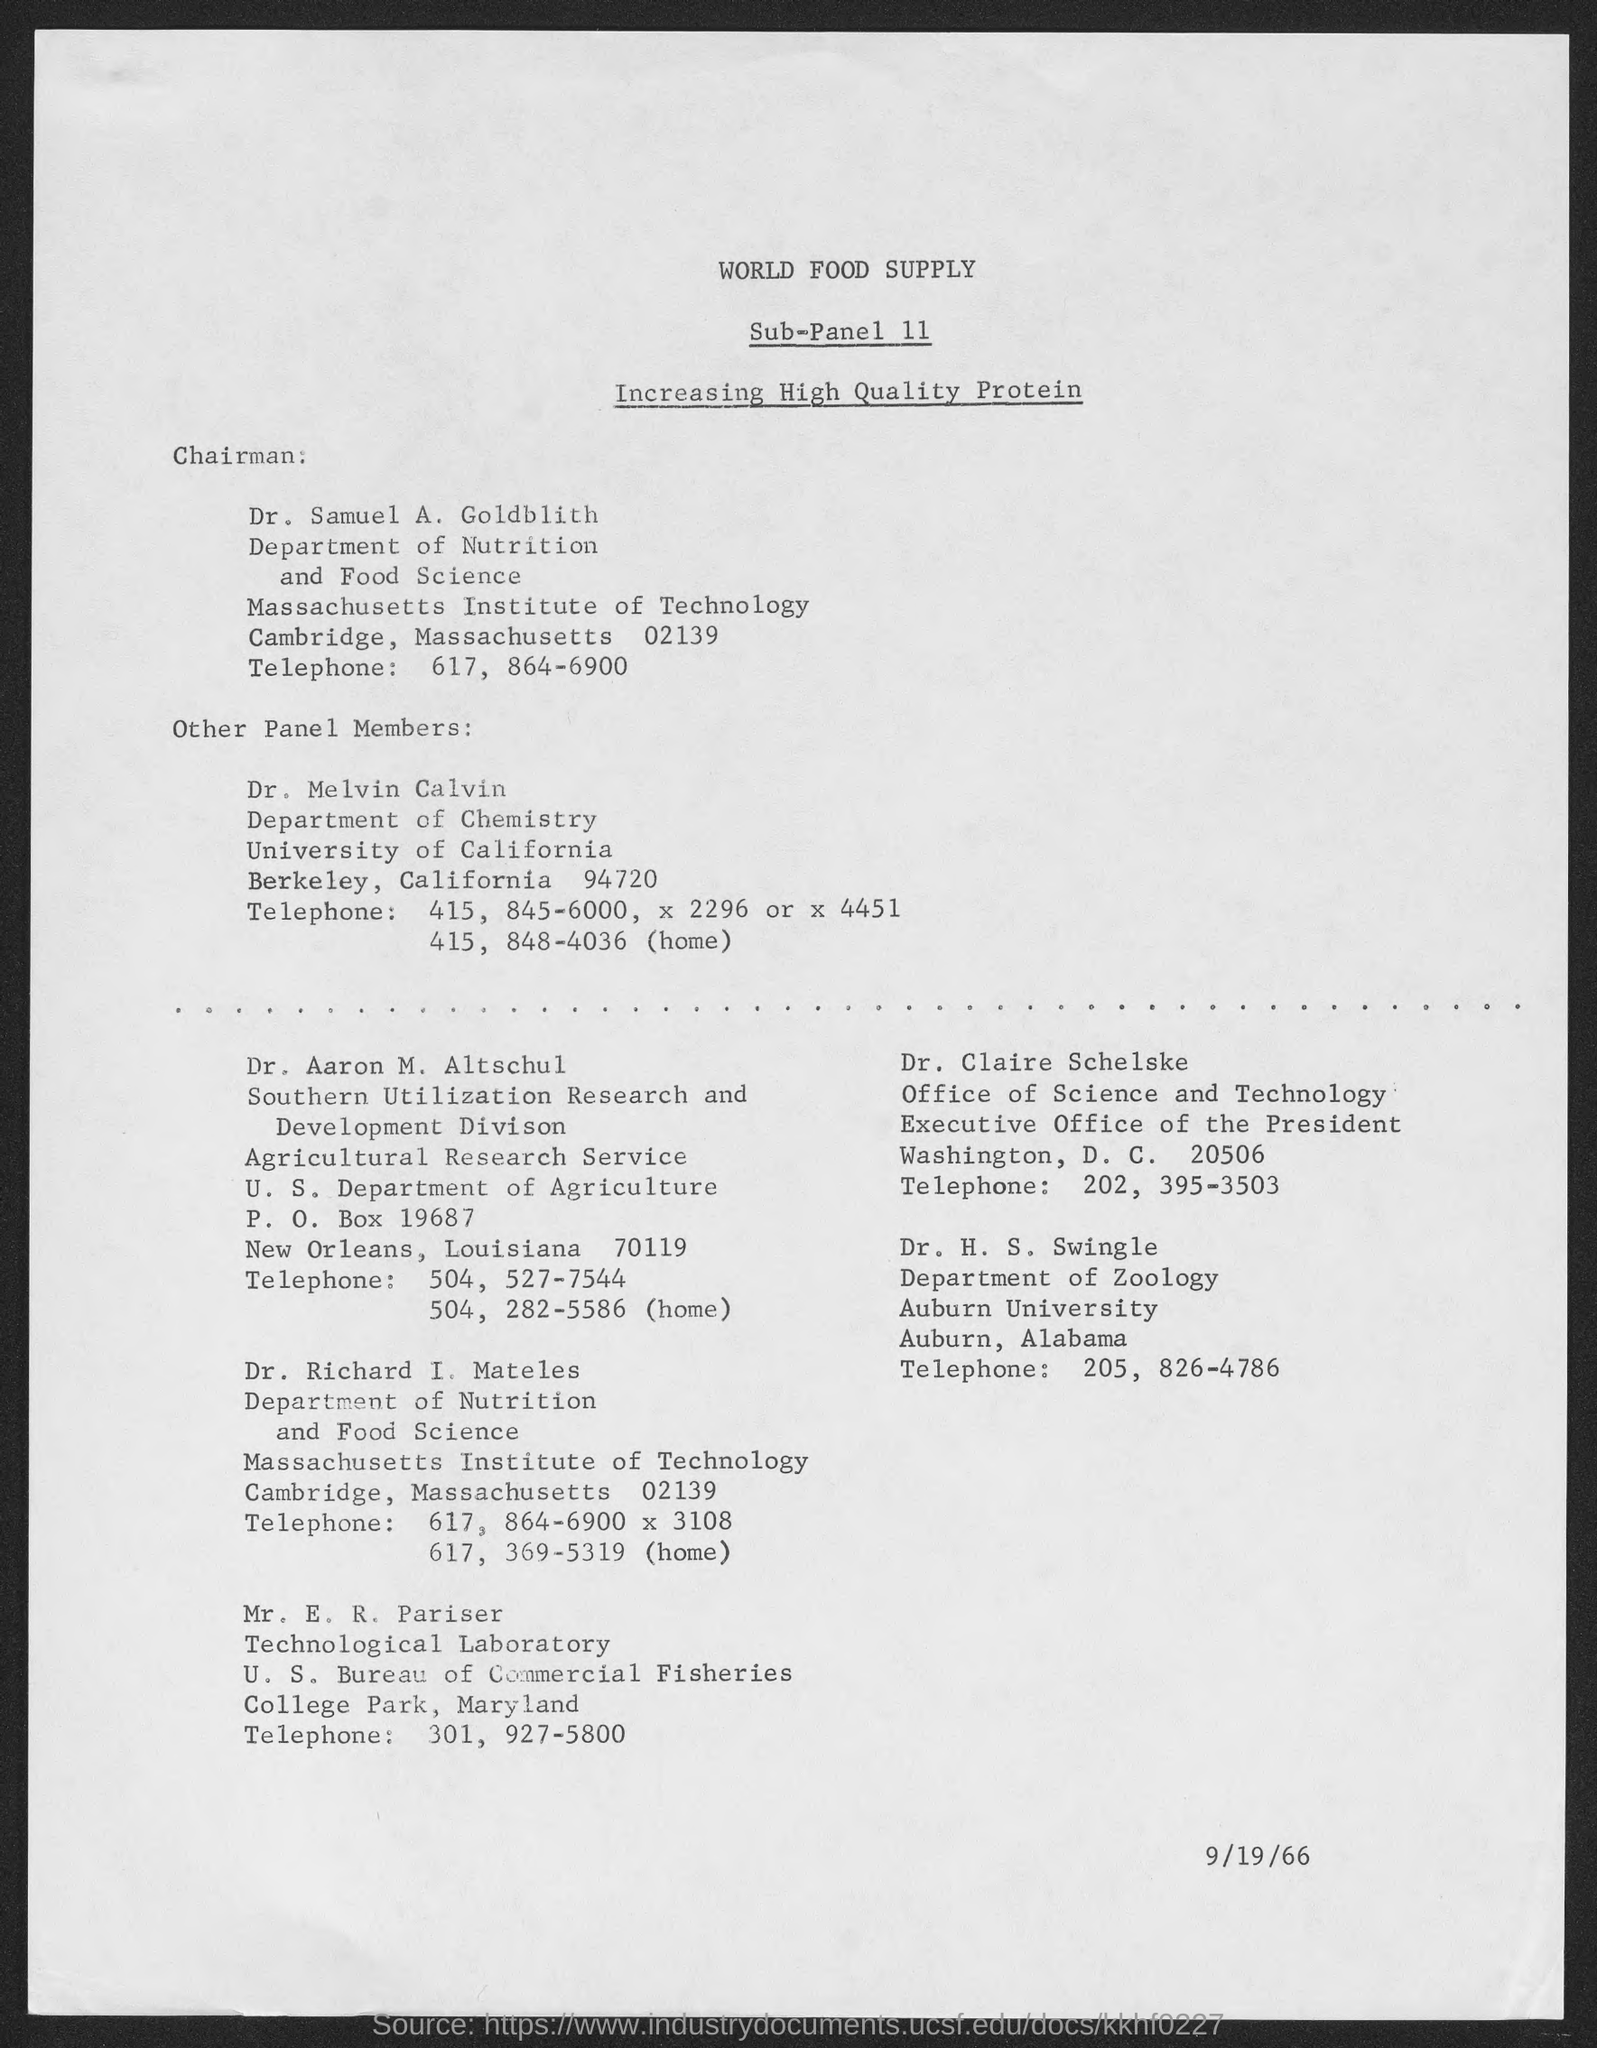What is the title of Sub-panel 11?
Ensure brevity in your answer.  Increasing high quality protein. Who is the Chairman?
Your answer should be compact. Dr. Samuel A. Goldblith. What is Dr. Samuel's telephone number?
Keep it short and to the point. 617, 864-6900. When is the document dated?
Offer a terse response. 9/19/66. Which department does Dr. H.S. Swingle belong to?
Provide a succinct answer. Department of Zoology. 